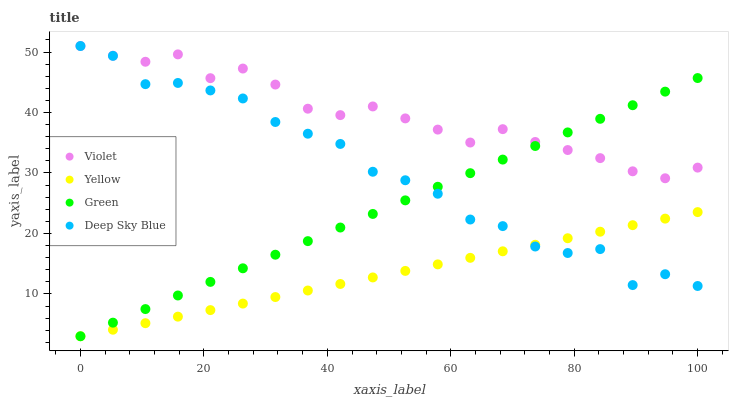Does Yellow have the minimum area under the curve?
Answer yes or no. Yes. Does Violet have the maximum area under the curve?
Answer yes or no. Yes. Does Deep Sky Blue have the minimum area under the curve?
Answer yes or no. No. Does Deep Sky Blue have the maximum area under the curve?
Answer yes or no. No. Is Yellow the smoothest?
Answer yes or no. Yes. Is Deep Sky Blue the roughest?
Answer yes or no. Yes. Is Deep Sky Blue the smoothest?
Answer yes or no. No. Is Yellow the roughest?
Answer yes or no. No. Does Green have the lowest value?
Answer yes or no. Yes. Does Deep Sky Blue have the lowest value?
Answer yes or no. No. Does Violet have the highest value?
Answer yes or no. Yes. Does Yellow have the highest value?
Answer yes or no. No. Is Yellow less than Violet?
Answer yes or no. Yes. Is Violet greater than Yellow?
Answer yes or no. Yes. Does Green intersect Deep Sky Blue?
Answer yes or no. Yes. Is Green less than Deep Sky Blue?
Answer yes or no. No. Is Green greater than Deep Sky Blue?
Answer yes or no. No. Does Yellow intersect Violet?
Answer yes or no. No. 